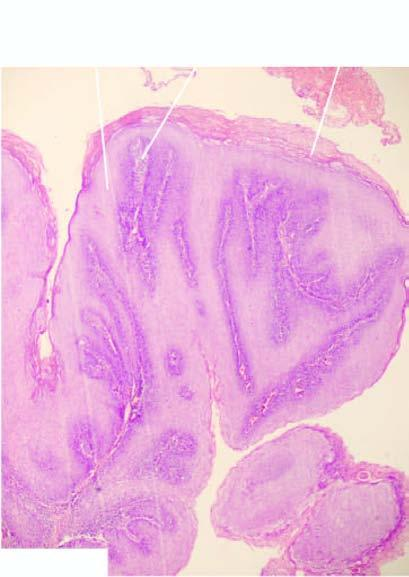what are papillae covered with?
Answer the question using a single word or phrase. Well oriented and orderly layers of squamous cells 